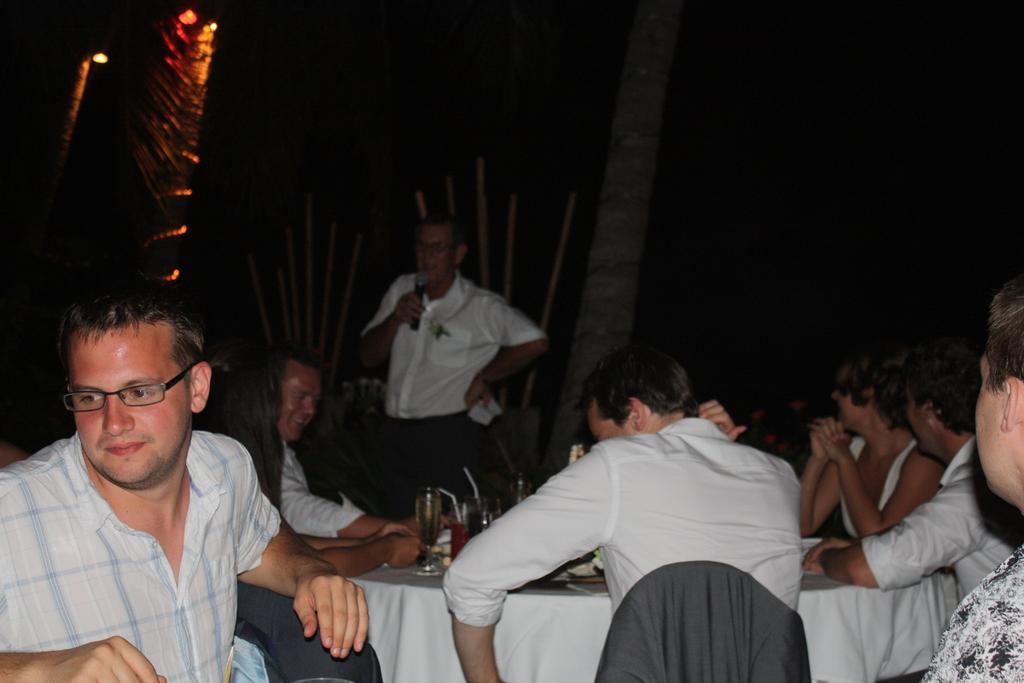Describe this image in one or two sentences. This picture is taken during night, in the picture there is a table in the middle, on the table there are some glasses, around the table there are few people, one person holding a mike standing beside the trunk of tree, in the top left there are some lights visible, background is dark. 